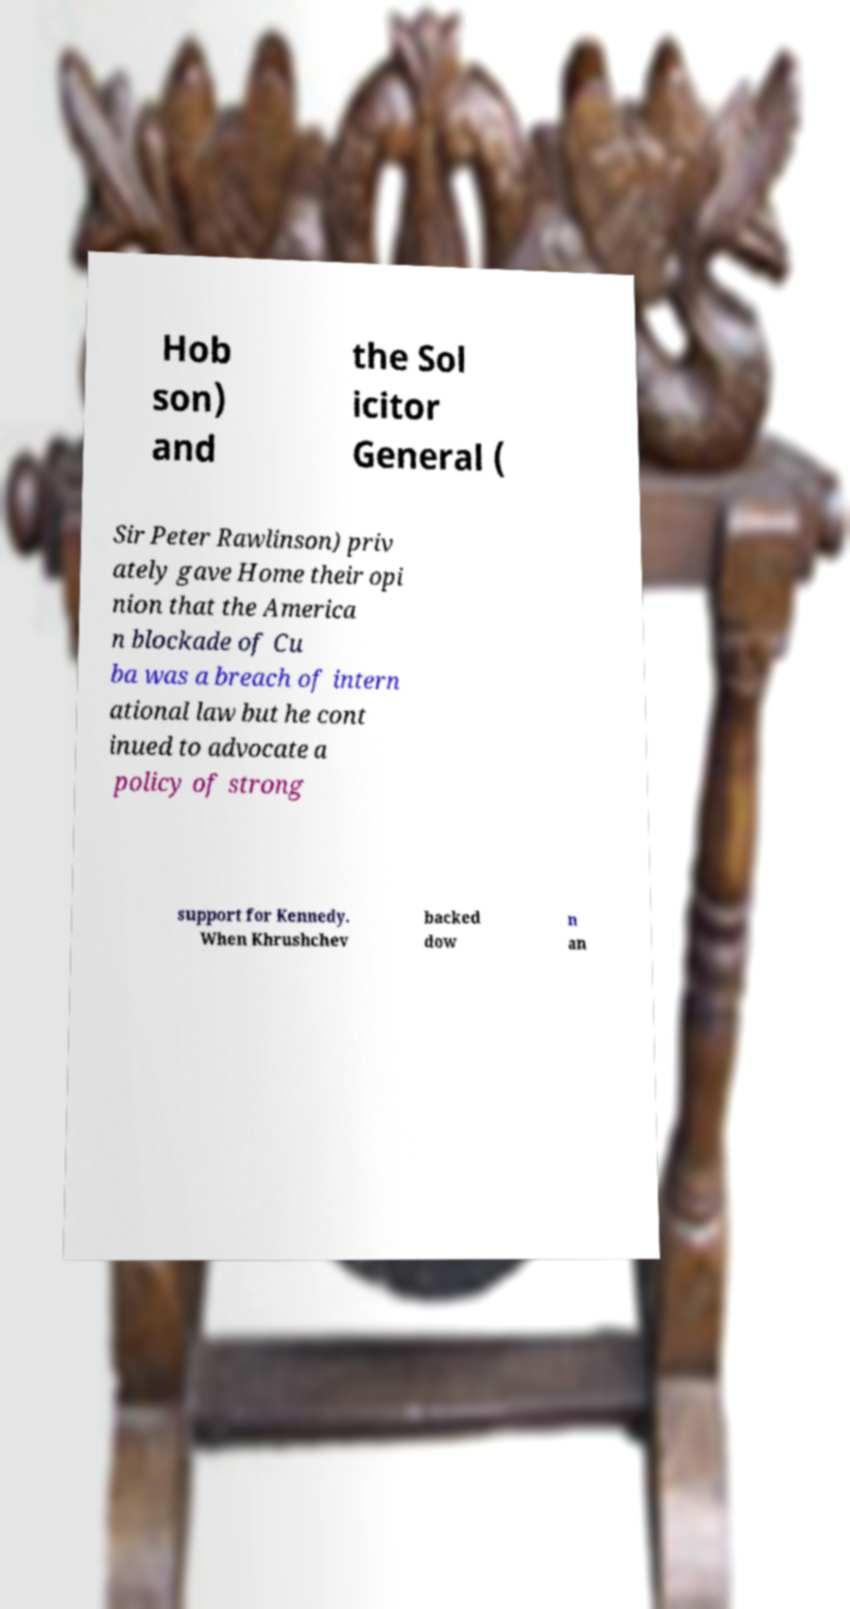What messages or text are displayed in this image? I need them in a readable, typed format. Hob son) and the Sol icitor General ( Sir Peter Rawlinson) priv ately gave Home their opi nion that the America n blockade of Cu ba was a breach of intern ational law but he cont inued to advocate a policy of strong support for Kennedy. When Khrushchev backed dow n an 